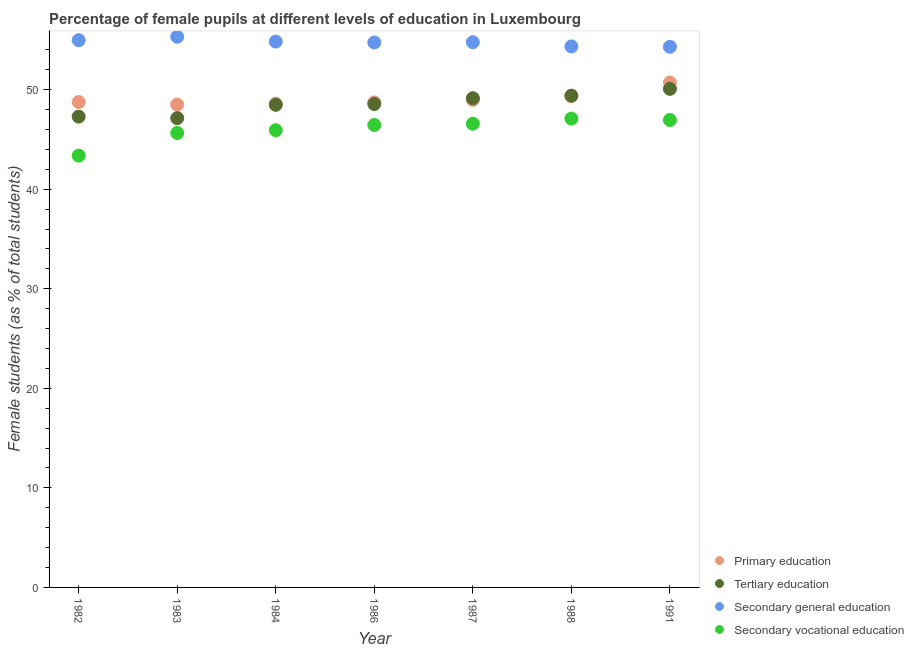Is the number of dotlines equal to the number of legend labels?
Give a very brief answer. Yes. What is the percentage of female students in secondary education in 1991?
Provide a succinct answer. 54.31. Across all years, what is the maximum percentage of female students in primary education?
Provide a succinct answer. 50.72. Across all years, what is the minimum percentage of female students in primary education?
Your response must be concise. 48.5. In which year was the percentage of female students in tertiary education maximum?
Ensure brevity in your answer.  1991. In which year was the percentage of female students in tertiary education minimum?
Your answer should be very brief. 1983. What is the total percentage of female students in secondary education in the graph?
Your answer should be very brief. 383.3. What is the difference between the percentage of female students in tertiary education in 1984 and that in 1986?
Give a very brief answer. -0.08. What is the difference between the percentage of female students in secondary vocational education in 1987 and the percentage of female students in secondary education in 1991?
Provide a short and direct response. -7.72. What is the average percentage of female students in secondary vocational education per year?
Provide a succinct answer. 46.01. In the year 1983, what is the difference between the percentage of female students in secondary education and percentage of female students in primary education?
Your answer should be very brief. 6.81. What is the ratio of the percentage of female students in tertiary education in 1984 to that in 1988?
Offer a very short reply. 0.98. Is the percentage of female students in tertiary education in 1982 less than that in 1987?
Keep it short and to the point. Yes. Is the difference between the percentage of female students in tertiary education in 1983 and 1988 greater than the difference between the percentage of female students in secondary education in 1983 and 1988?
Offer a very short reply. No. What is the difference between the highest and the second highest percentage of female students in primary education?
Keep it short and to the point. 1.38. What is the difference between the highest and the lowest percentage of female students in secondary vocational education?
Offer a very short reply. 3.72. Is it the case that in every year, the sum of the percentage of female students in tertiary education and percentage of female students in secondary education is greater than the sum of percentage of female students in secondary vocational education and percentage of female students in primary education?
Provide a short and direct response. No. Is it the case that in every year, the sum of the percentage of female students in primary education and percentage of female students in tertiary education is greater than the percentage of female students in secondary education?
Ensure brevity in your answer.  Yes. Does the percentage of female students in secondary education monotonically increase over the years?
Give a very brief answer. No. Is the percentage of female students in primary education strictly greater than the percentage of female students in secondary education over the years?
Ensure brevity in your answer.  No. How many dotlines are there?
Offer a terse response. 4. How many years are there in the graph?
Your response must be concise. 7. What is the difference between two consecutive major ticks on the Y-axis?
Your answer should be very brief. 10. Are the values on the major ticks of Y-axis written in scientific E-notation?
Your answer should be compact. No. Does the graph contain grids?
Offer a terse response. No. How many legend labels are there?
Your answer should be very brief. 4. What is the title of the graph?
Your response must be concise. Percentage of female pupils at different levels of education in Luxembourg. What is the label or title of the X-axis?
Your answer should be compact. Year. What is the label or title of the Y-axis?
Give a very brief answer. Female students (as % of total students). What is the Female students (as % of total students) of Primary education in 1982?
Ensure brevity in your answer.  48.76. What is the Female students (as % of total students) in Tertiary education in 1982?
Your answer should be very brief. 47.3. What is the Female students (as % of total students) of Secondary general education in 1982?
Provide a succinct answer. 54.98. What is the Female students (as % of total students) of Secondary vocational education in 1982?
Make the answer very short. 43.38. What is the Female students (as % of total students) in Primary education in 1983?
Your response must be concise. 48.5. What is the Female students (as % of total students) of Tertiary education in 1983?
Provide a succinct answer. 47.14. What is the Female students (as % of total students) in Secondary general education in 1983?
Offer a very short reply. 55.32. What is the Female students (as % of total students) of Secondary vocational education in 1983?
Offer a terse response. 45.65. What is the Female students (as % of total students) of Primary education in 1984?
Keep it short and to the point. 48.6. What is the Female students (as % of total students) in Tertiary education in 1984?
Your answer should be compact. 48.48. What is the Female students (as % of total students) in Secondary general education in 1984?
Your answer should be compact. 54.83. What is the Female students (as % of total students) in Secondary vocational education in 1984?
Your answer should be compact. 45.93. What is the Female students (as % of total students) of Primary education in 1986?
Your answer should be very brief. 48.73. What is the Female students (as % of total students) of Tertiary education in 1986?
Keep it short and to the point. 48.56. What is the Female students (as % of total students) of Secondary general education in 1986?
Make the answer very short. 54.74. What is the Female students (as % of total students) in Secondary vocational education in 1986?
Ensure brevity in your answer.  46.46. What is the Female students (as % of total students) in Primary education in 1987?
Give a very brief answer. 48.98. What is the Female students (as % of total students) of Tertiary education in 1987?
Your response must be concise. 49.15. What is the Female students (as % of total students) of Secondary general education in 1987?
Your answer should be very brief. 54.77. What is the Female students (as % of total students) of Secondary vocational education in 1987?
Your answer should be very brief. 46.58. What is the Female students (as % of total students) of Primary education in 1988?
Your answer should be compact. 49.34. What is the Female students (as % of total students) in Tertiary education in 1988?
Make the answer very short. 49.41. What is the Female students (as % of total students) of Secondary general education in 1988?
Give a very brief answer. 54.35. What is the Female students (as % of total students) in Secondary vocational education in 1988?
Your answer should be compact. 47.1. What is the Female students (as % of total students) in Primary education in 1991?
Give a very brief answer. 50.72. What is the Female students (as % of total students) of Tertiary education in 1991?
Offer a very short reply. 50.08. What is the Female students (as % of total students) in Secondary general education in 1991?
Offer a very short reply. 54.31. What is the Female students (as % of total students) in Secondary vocational education in 1991?
Keep it short and to the point. 46.96. Across all years, what is the maximum Female students (as % of total students) in Primary education?
Your response must be concise. 50.72. Across all years, what is the maximum Female students (as % of total students) in Tertiary education?
Offer a terse response. 50.08. Across all years, what is the maximum Female students (as % of total students) in Secondary general education?
Your answer should be very brief. 55.32. Across all years, what is the maximum Female students (as % of total students) in Secondary vocational education?
Your answer should be very brief. 47.1. Across all years, what is the minimum Female students (as % of total students) in Primary education?
Your response must be concise. 48.5. Across all years, what is the minimum Female students (as % of total students) in Tertiary education?
Give a very brief answer. 47.14. Across all years, what is the minimum Female students (as % of total students) in Secondary general education?
Provide a succinct answer. 54.31. Across all years, what is the minimum Female students (as % of total students) of Secondary vocational education?
Provide a succinct answer. 43.38. What is the total Female students (as % of total students) of Primary education in the graph?
Ensure brevity in your answer.  343.64. What is the total Female students (as % of total students) of Tertiary education in the graph?
Offer a terse response. 340.12. What is the total Female students (as % of total students) of Secondary general education in the graph?
Ensure brevity in your answer.  383.3. What is the total Female students (as % of total students) of Secondary vocational education in the graph?
Provide a succinct answer. 322.06. What is the difference between the Female students (as % of total students) of Primary education in 1982 and that in 1983?
Keep it short and to the point. 0.26. What is the difference between the Female students (as % of total students) in Tertiary education in 1982 and that in 1983?
Offer a very short reply. 0.15. What is the difference between the Female students (as % of total students) of Secondary general education in 1982 and that in 1983?
Keep it short and to the point. -0.34. What is the difference between the Female students (as % of total students) in Secondary vocational education in 1982 and that in 1983?
Give a very brief answer. -2.27. What is the difference between the Female students (as % of total students) of Primary education in 1982 and that in 1984?
Provide a short and direct response. 0.16. What is the difference between the Female students (as % of total students) of Tertiary education in 1982 and that in 1984?
Offer a terse response. -1.18. What is the difference between the Female students (as % of total students) of Secondary general education in 1982 and that in 1984?
Your answer should be very brief. 0.14. What is the difference between the Female students (as % of total students) of Secondary vocational education in 1982 and that in 1984?
Ensure brevity in your answer.  -2.55. What is the difference between the Female students (as % of total students) of Primary education in 1982 and that in 1986?
Keep it short and to the point. 0.04. What is the difference between the Female students (as % of total students) in Tertiary education in 1982 and that in 1986?
Your answer should be compact. -1.27. What is the difference between the Female students (as % of total students) in Secondary general education in 1982 and that in 1986?
Your answer should be compact. 0.24. What is the difference between the Female students (as % of total students) in Secondary vocational education in 1982 and that in 1986?
Make the answer very short. -3.08. What is the difference between the Female students (as % of total students) in Primary education in 1982 and that in 1987?
Provide a short and direct response. -0.22. What is the difference between the Female students (as % of total students) in Tertiary education in 1982 and that in 1987?
Provide a succinct answer. -1.85. What is the difference between the Female students (as % of total students) of Secondary general education in 1982 and that in 1987?
Ensure brevity in your answer.  0.2. What is the difference between the Female students (as % of total students) in Secondary vocational education in 1982 and that in 1987?
Give a very brief answer. -3.2. What is the difference between the Female students (as % of total students) of Primary education in 1982 and that in 1988?
Your response must be concise. -0.58. What is the difference between the Female students (as % of total students) of Tertiary education in 1982 and that in 1988?
Offer a terse response. -2.11. What is the difference between the Female students (as % of total students) in Secondary general education in 1982 and that in 1988?
Ensure brevity in your answer.  0.63. What is the difference between the Female students (as % of total students) of Secondary vocational education in 1982 and that in 1988?
Your answer should be very brief. -3.72. What is the difference between the Female students (as % of total students) in Primary education in 1982 and that in 1991?
Keep it short and to the point. -1.96. What is the difference between the Female students (as % of total students) in Tertiary education in 1982 and that in 1991?
Keep it short and to the point. -2.79. What is the difference between the Female students (as % of total students) of Secondary general education in 1982 and that in 1991?
Give a very brief answer. 0.67. What is the difference between the Female students (as % of total students) of Secondary vocational education in 1982 and that in 1991?
Make the answer very short. -3.58. What is the difference between the Female students (as % of total students) of Primary education in 1983 and that in 1984?
Make the answer very short. -0.1. What is the difference between the Female students (as % of total students) of Tertiary education in 1983 and that in 1984?
Your response must be concise. -1.34. What is the difference between the Female students (as % of total students) in Secondary general education in 1983 and that in 1984?
Provide a succinct answer. 0.48. What is the difference between the Female students (as % of total students) of Secondary vocational education in 1983 and that in 1984?
Your response must be concise. -0.28. What is the difference between the Female students (as % of total students) of Primary education in 1983 and that in 1986?
Provide a short and direct response. -0.22. What is the difference between the Female students (as % of total students) in Tertiary education in 1983 and that in 1986?
Your answer should be compact. -1.42. What is the difference between the Female students (as % of total students) of Secondary general education in 1983 and that in 1986?
Ensure brevity in your answer.  0.58. What is the difference between the Female students (as % of total students) in Secondary vocational education in 1983 and that in 1986?
Your answer should be compact. -0.8. What is the difference between the Female students (as % of total students) of Primary education in 1983 and that in 1987?
Offer a very short reply. -0.48. What is the difference between the Female students (as % of total students) in Tertiary education in 1983 and that in 1987?
Offer a very short reply. -2. What is the difference between the Female students (as % of total students) in Secondary general education in 1983 and that in 1987?
Keep it short and to the point. 0.55. What is the difference between the Female students (as % of total students) of Secondary vocational education in 1983 and that in 1987?
Give a very brief answer. -0.93. What is the difference between the Female students (as % of total students) of Primary education in 1983 and that in 1988?
Ensure brevity in your answer.  -0.84. What is the difference between the Female students (as % of total students) of Tertiary education in 1983 and that in 1988?
Give a very brief answer. -2.26. What is the difference between the Female students (as % of total students) in Secondary general education in 1983 and that in 1988?
Ensure brevity in your answer.  0.97. What is the difference between the Female students (as % of total students) in Secondary vocational education in 1983 and that in 1988?
Make the answer very short. -1.44. What is the difference between the Female students (as % of total students) in Primary education in 1983 and that in 1991?
Provide a short and direct response. -2.22. What is the difference between the Female students (as % of total students) in Tertiary education in 1983 and that in 1991?
Your answer should be compact. -2.94. What is the difference between the Female students (as % of total students) of Secondary general education in 1983 and that in 1991?
Ensure brevity in your answer.  1.01. What is the difference between the Female students (as % of total students) of Secondary vocational education in 1983 and that in 1991?
Offer a terse response. -1.3. What is the difference between the Female students (as % of total students) in Primary education in 1984 and that in 1986?
Make the answer very short. -0.12. What is the difference between the Female students (as % of total students) of Tertiary education in 1984 and that in 1986?
Your answer should be very brief. -0.08. What is the difference between the Female students (as % of total students) of Secondary general education in 1984 and that in 1986?
Ensure brevity in your answer.  0.09. What is the difference between the Female students (as % of total students) of Secondary vocational education in 1984 and that in 1986?
Ensure brevity in your answer.  -0.52. What is the difference between the Female students (as % of total students) in Primary education in 1984 and that in 1987?
Ensure brevity in your answer.  -0.38. What is the difference between the Female students (as % of total students) of Tertiary education in 1984 and that in 1987?
Keep it short and to the point. -0.67. What is the difference between the Female students (as % of total students) of Secondary general education in 1984 and that in 1987?
Keep it short and to the point. 0.06. What is the difference between the Female students (as % of total students) of Secondary vocational education in 1984 and that in 1987?
Provide a succinct answer. -0.65. What is the difference between the Female students (as % of total students) in Primary education in 1984 and that in 1988?
Your response must be concise. -0.74. What is the difference between the Female students (as % of total students) in Tertiary education in 1984 and that in 1988?
Ensure brevity in your answer.  -0.93. What is the difference between the Female students (as % of total students) in Secondary general education in 1984 and that in 1988?
Make the answer very short. 0.49. What is the difference between the Female students (as % of total students) in Secondary vocational education in 1984 and that in 1988?
Your answer should be very brief. -1.17. What is the difference between the Female students (as % of total students) of Primary education in 1984 and that in 1991?
Offer a terse response. -2.12. What is the difference between the Female students (as % of total students) in Tertiary education in 1984 and that in 1991?
Your answer should be very brief. -1.6. What is the difference between the Female students (as % of total students) of Secondary general education in 1984 and that in 1991?
Your answer should be compact. 0.53. What is the difference between the Female students (as % of total students) of Secondary vocational education in 1984 and that in 1991?
Offer a terse response. -1.03. What is the difference between the Female students (as % of total students) in Primary education in 1986 and that in 1987?
Offer a very short reply. -0.26. What is the difference between the Female students (as % of total students) of Tertiary education in 1986 and that in 1987?
Make the answer very short. -0.58. What is the difference between the Female students (as % of total students) of Secondary general education in 1986 and that in 1987?
Your answer should be very brief. -0.03. What is the difference between the Female students (as % of total students) in Secondary vocational education in 1986 and that in 1987?
Provide a short and direct response. -0.13. What is the difference between the Female students (as % of total students) in Primary education in 1986 and that in 1988?
Your answer should be very brief. -0.62. What is the difference between the Female students (as % of total students) in Tertiary education in 1986 and that in 1988?
Give a very brief answer. -0.84. What is the difference between the Female students (as % of total students) in Secondary general education in 1986 and that in 1988?
Make the answer very short. 0.39. What is the difference between the Female students (as % of total students) of Secondary vocational education in 1986 and that in 1988?
Offer a very short reply. -0.64. What is the difference between the Female students (as % of total students) in Primary education in 1986 and that in 1991?
Give a very brief answer. -2. What is the difference between the Female students (as % of total students) of Tertiary education in 1986 and that in 1991?
Provide a succinct answer. -1.52. What is the difference between the Female students (as % of total students) of Secondary general education in 1986 and that in 1991?
Give a very brief answer. 0.43. What is the difference between the Female students (as % of total students) of Secondary vocational education in 1986 and that in 1991?
Give a very brief answer. -0.5. What is the difference between the Female students (as % of total students) in Primary education in 1987 and that in 1988?
Give a very brief answer. -0.36. What is the difference between the Female students (as % of total students) in Tertiary education in 1987 and that in 1988?
Give a very brief answer. -0.26. What is the difference between the Female students (as % of total students) of Secondary general education in 1987 and that in 1988?
Offer a very short reply. 0.42. What is the difference between the Female students (as % of total students) of Secondary vocational education in 1987 and that in 1988?
Provide a succinct answer. -0.51. What is the difference between the Female students (as % of total students) of Primary education in 1987 and that in 1991?
Give a very brief answer. -1.74. What is the difference between the Female students (as % of total students) in Tertiary education in 1987 and that in 1991?
Provide a succinct answer. -0.94. What is the difference between the Female students (as % of total students) of Secondary general education in 1987 and that in 1991?
Your answer should be compact. 0.46. What is the difference between the Female students (as % of total students) of Secondary vocational education in 1987 and that in 1991?
Ensure brevity in your answer.  -0.37. What is the difference between the Female students (as % of total students) of Primary education in 1988 and that in 1991?
Your response must be concise. -1.38. What is the difference between the Female students (as % of total students) in Tertiary education in 1988 and that in 1991?
Provide a succinct answer. -0.68. What is the difference between the Female students (as % of total students) of Secondary general education in 1988 and that in 1991?
Make the answer very short. 0.04. What is the difference between the Female students (as % of total students) of Secondary vocational education in 1988 and that in 1991?
Provide a short and direct response. 0.14. What is the difference between the Female students (as % of total students) of Primary education in 1982 and the Female students (as % of total students) of Tertiary education in 1983?
Your answer should be very brief. 1.62. What is the difference between the Female students (as % of total students) in Primary education in 1982 and the Female students (as % of total students) in Secondary general education in 1983?
Your answer should be very brief. -6.56. What is the difference between the Female students (as % of total students) of Primary education in 1982 and the Female students (as % of total students) of Secondary vocational education in 1983?
Provide a short and direct response. 3.11. What is the difference between the Female students (as % of total students) of Tertiary education in 1982 and the Female students (as % of total students) of Secondary general education in 1983?
Your response must be concise. -8.02. What is the difference between the Female students (as % of total students) in Tertiary education in 1982 and the Female students (as % of total students) in Secondary vocational education in 1983?
Offer a terse response. 1.64. What is the difference between the Female students (as % of total students) in Secondary general education in 1982 and the Female students (as % of total students) in Secondary vocational education in 1983?
Make the answer very short. 9.32. What is the difference between the Female students (as % of total students) of Primary education in 1982 and the Female students (as % of total students) of Tertiary education in 1984?
Keep it short and to the point. 0.28. What is the difference between the Female students (as % of total students) of Primary education in 1982 and the Female students (as % of total students) of Secondary general education in 1984?
Keep it short and to the point. -6.07. What is the difference between the Female students (as % of total students) of Primary education in 1982 and the Female students (as % of total students) of Secondary vocational education in 1984?
Offer a very short reply. 2.83. What is the difference between the Female students (as % of total students) in Tertiary education in 1982 and the Female students (as % of total students) in Secondary general education in 1984?
Provide a succinct answer. -7.54. What is the difference between the Female students (as % of total students) in Tertiary education in 1982 and the Female students (as % of total students) in Secondary vocational education in 1984?
Your answer should be very brief. 1.36. What is the difference between the Female students (as % of total students) of Secondary general education in 1982 and the Female students (as % of total students) of Secondary vocational education in 1984?
Offer a very short reply. 9.05. What is the difference between the Female students (as % of total students) of Primary education in 1982 and the Female students (as % of total students) of Tertiary education in 1986?
Ensure brevity in your answer.  0.2. What is the difference between the Female students (as % of total students) in Primary education in 1982 and the Female students (as % of total students) in Secondary general education in 1986?
Keep it short and to the point. -5.98. What is the difference between the Female students (as % of total students) in Primary education in 1982 and the Female students (as % of total students) in Secondary vocational education in 1986?
Ensure brevity in your answer.  2.31. What is the difference between the Female students (as % of total students) of Tertiary education in 1982 and the Female students (as % of total students) of Secondary general education in 1986?
Your answer should be very brief. -7.45. What is the difference between the Female students (as % of total students) in Tertiary education in 1982 and the Female students (as % of total students) in Secondary vocational education in 1986?
Make the answer very short. 0.84. What is the difference between the Female students (as % of total students) in Secondary general education in 1982 and the Female students (as % of total students) in Secondary vocational education in 1986?
Offer a very short reply. 8.52. What is the difference between the Female students (as % of total students) in Primary education in 1982 and the Female students (as % of total students) in Tertiary education in 1987?
Your answer should be compact. -0.38. What is the difference between the Female students (as % of total students) in Primary education in 1982 and the Female students (as % of total students) in Secondary general education in 1987?
Your answer should be compact. -6.01. What is the difference between the Female students (as % of total students) of Primary education in 1982 and the Female students (as % of total students) of Secondary vocational education in 1987?
Your response must be concise. 2.18. What is the difference between the Female students (as % of total students) in Tertiary education in 1982 and the Female students (as % of total students) in Secondary general education in 1987?
Provide a short and direct response. -7.48. What is the difference between the Female students (as % of total students) in Tertiary education in 1982 and the Female students (as % of total students) in Secondary vocational education in 1987?
Your response must be concise. 0.71. What is the difference between the Female students (as % of total students) in Secondary general education in 1982 and the Female students (as % of total students) in Secondary vocational education in 1987?
Offer a terse response. 8.39. What is the difference between the Female students (as % of total students) of Primary education in 1982 and the Female students (as % of total students) of Tertiary education in 1988?
Offer a very short reply. -0.64. What is the difference between the Female students (as % of total students) of Primary education in 1982 and the Female students (as % of total students) of Secondary general education in 1988?
Ensure brevity in your answer.  -5.59. What is the difference between the Female students (as % of total students) of Primary education in 1982 and the Female students (as % of total students) of Secondary vocational education in 1988?
Your answer should be compact. 1.66. What is the difference between the Female students (as % of total students) of Tertiary education in 1982 and the Female students (as % of total students) of Secondary general education in 1988?
Provide a short and direct response. -7.05. What is the difference between the Female students (as % of total students) in Tertiary education in 1982 and the Female students (as % of total students) in Secondary vocational education in 1988?
Your response must be concise. 0.2. What is the difference between the Female students (as % of total students) of Secondary general education in 1982 and the Female students (as % of total students) of Secondary vocational education in 1988?
Offer a terse response. 7.88. What is the difference between the Female students (as % of total students) in Primary education in 1982 and the Female students (as % of total students) in Tertiary education in 1991?
Offer a very short reply. -1.32. What is the difference between the Female students (as % of total students) in Primary education in 1982 and the Female students (as % of total students) in Secondary general education in 1991?
Your answer should be very brief. -5.55. What is the difference between the Female students (as % of total students) of Primary education in 1982 and the Female students (as % of total students) of Secondary vocational education in 1991?
Provide a succinct answer. 1.8. What is the difference between the Female students (as % of total students) in Tertiary education in 1982 and the Female students (as % of total students) in Secondary general education in 1991?
Ensure brevity in your answer.  -7.01. What is the difference between the Female students (as % of total students) of Tertiary education in 1982 and the Female students (as % of total students) of Secondary vocational education in 1991?
Your response must be concise. 0.34. What is the difference between the Female students (as % of total students) in Secondary general education in 1982 and the Female students (as % of total students) in Secondary vocational education in 1991?
Provide a succinct answer. 8.02. What is the difference between the Female students (as % of total students) of Primary education in 1983 and the Female students (as % of total students) of Tertiary education in 1984?
Make the answer very short. 0.02. What is the difference between the Female students (as % of total students) of Primary education in 1983 and the Female students (as % of total students) of Secondary general education in 1984?
Offer a very short reply. -6.33. What is the difference between the Female students (as % of total students) in Primary education in 1983 and the Female students (as % of total students) in Secondary vocational education in 1984?
Offer a terse response. 2.57. What is the difference between the Female students (as % of total students) in Tertiary education in 1983 and the Female students (as % of total students) in Secondary general education in 1984?
Offer a very short reply. -7.69. What is the difference between the Female students (as % of total students) of Tertiary education in 1983 and the Female students (as % of total students) of Secondary vocational education in 1984?
Offer a terse response. 1.21. What is the difference between the Female students (as % of total students) in Secondary general education in 1983 and the Female students (as % of total students) in Secondary vocational education in 1984?
Give a very brief answer. 9.39. What is the difference between the Female students (as % of total students) in Primary education in 1983 and the Female students (as % of total students) in Tertiary education in 1986?
Your answer should be compact. -0.06. What is the difference between the Female students (as % of total students) in Primary education in 1983 and the Female students (as % of total students) in Secondary general education in 1986?
Provide a succinct answer. -6.24. What is the difference between the Female students (as % of total students) of Primary education in 1983 and the Female students (as % of total students) of Secondary vocational education in 1986?
Ensure brevity in your answer.  2.05. What is the difference between the Female students (as % of total students) in Tertiary education in 1983 and the Female students (as % of total students) in Secondary general education in 1986?
Give a very brief answer. -7.6. What is the difference between the Female students (as % of total students) in Tertiary education in 1983 and the Female students (as % of total students) in Secondary vocational education in 1986?
Offer a very short reply. 0.69. What is the difference between the Female students (as % of total students) in Secondary general education in 1983 and the Female students (as % of total students) in Secondary vocational education in 1986?
Ensure brevity in your answer.  8.86. What is the difference between the Female students (as % of total students) of Primary education in 1983 and the Female students (as % of total students) of Tertiary education in 1987?
Your answer should be compact. -0.64. What is the difference between the Female students (as % of total students) of Primary education in 1983 and the Female students (as % of total students) of Secondary general education in 1987?
Offer a very short reply. -6.27. What is the difference between the Female students (as % of total students) of Primary education in 1983 and the Female students (as % of total students) of Secondary vocational education in 1987?
Offer a terse response. 1.92. What is the difference between the Female students (as % of total students) of Tertiary education in 1983 and the Female students (as % of total students) of Secondary general education in 1987?
Your answer should be compact. -7.63. What is the difference between the Female students (as % of total students) of Tertiary education in 1983 and the Female students (as % of total students) of Secondary vocational education in 1987?
Your response must be concise. 0.56. What is the difference between the Female students (as % of total students) in Secondary general education in 1983 and the Female students (as % of total students) in Secondary vocational education in 1987?
Give a very brief answer. 8.73. What is the difference between the Female students (as % of total students) of Primary education in 1983 and the Female students (as % of total students) of Tertiary education in 1988?
Provide a succinct answer. -0.9. What is the difference between the Female students (as % of total students) of Primary education in 1983 and the Female students (as % of total students) of Secondary general education in 1988?
Ensure brevity in your answer.  -5.85. What is the difference between the Female students (as % of total students) of Primary education in 1983 and the Female students (as % of total students) of Secondary vocational education in 1988?
Keep it short and to the point. 1.4. What is the difference between the Female students (as % of total students) in Tertiary education in 1983 and the Female students (as % of total students) in Secondary general education in 1988?
Offer a terse response. -7.2. What is the difference between the Female students (as % of total students) of Tertiary education in 1983 and the Female students (as % of total students) of Secondary vocational education in 1988?
Make the answer very short. 0.05. What is the difference between the Female students (as % of total students) in Secondary general education in 1983 and the Female students (as % of total students) in Secondary vocational education in 1988?
Your answer should be very brief. 8.22. What is the difference between the Female students (as % of total students) of Primary education in 1983 and the Female students (as % of total students) of Tertiary education in 1991?
Offer a terse response. -1.58. What is the difference between the Female students (as % of total students) of Primary education in 1983 and the Female students (as % of total students) of Secondary general education in 1991?
Your answer should be compact. -5.81. What is the difference between the Female students (as % of total students) in Primary education in 1983 and the Female students (as % of total students) in Secondary vocational education in 1991?
Your answer should be very brief. 1.54. What is the difference between the Female students (as % of total students) in Tertiary education in 1983 and the Female students (as % of total students) in Secondary general education in 1991?
Your response must be concise. -7.16. What is the difference between the Female students (as % of total students) in Tertiary education in 1983 and the Female students (as % of total students) in Secondary vocational education in 1991?
Keep it short and to the point. 0.19. What is the difference between the Female students (as % of total students) of Secondary general education in 1983 and the Female students (as % of total students) of Secondary vocational education in 1991?
Give a very brief answer. 8.36. What is the difference between the Female students (as % of total students) in Primary education in 1984 and the Female students (as % of total students) in Tertiary education in 1986?
Keep it short and to the point. 0.04. What is the difference between the Female students (as % of total students) in Primary education in 1984 and the Female students (as % of total students) in Secondary general education in 1986?
Your answer should be compact. -6.14. What is the difference between the Female students (as % of total students) of Primary education in 1984 and the Female students (as % of total students) of Secondary vocational education in 1986?
Make the answer very short. 2.14. What is the difference between the Female students (as % of total students) of Tertiary education in 1984 and the Female students (as % of total students) of Secondary general education in 1986?
Ensure brevity in your answer.  -6.26. What is the difference between the Female students (as % of total students) in Tertiary education in 1984 and the Female students (as % of total students) in Secondary vocational education in 1986?
Offer a terse response. 2.02. What is the difference between the Female students (as % of total students) of Secondary general education in 1984 and the Female students (as % of total students) of Secondary vocational education in 1986?
Your answer should be very brief. 8.38. What is the difference between the Female students (as % of total students) of Primary education in 1984 and the Female students (as % of total students) of Tertiary education in 1987?
Your answer should be compact. -0.55. What is the difference between the Female students (as % of total students) of Primary education in 1984 and the Female students (as % of total students) of Secondary general education in 1987?
Your response must be concise. -6.17. What is the difference between the Female students (as % of total students) of Primary education in 1984 and the Female students (as % of total students) of Secondary vocational education in 1987?
Keep it short and to the point. 2.02. What is the difference between the Female students (as % of total students) in Tertiary education in 1984 and the Female students (as % of total students) in Secondary general education in 1987?
Offer a terse response. -6.29. What is the difference between the Female students (as % of total students) in Tertiary education in 1984 and the Female students (as % of total students) in Secondary vocational education in 1987?
Offer a very short reply. 1.9. What is the difference between the Female students (as % of total students) in Secondary general education in 1984 and the Female students (as % of total students) in Secondary vocational education in 1987?
Your answer should be very brief. 8.25. What is the difference between the Female students (as % of total students) in Primary education in 1984 and the Female students (as % of total students) in Tertiary education in 1988?
Ensure brevity in your answer.  -0.81. What is the difference between the Female students (as % of total students) of Primary education in 1984 and the Female students (as % of total students) of Secondary general education in 1988?
Make the answer very short. -5.75. What is the difference between the Female students (as % of total students) in Primary education in 1984 and the Female students (as % of total students) in Secondary vocational education in 1988?
Provide a short and direct response. 1.5. What is the difference between the Female students (as % of total students) in Tertiary education in 1984 and the Female students (as % of total students) in Secondary general education in 1988?
Your response must be concise. -5.87. What is the difference between the Female students (as % of total students) of Tertiary education in 1984 and the Female students (as % of total students) of Secondary vocational education in 1988?
Provide a short and direct response. 1.38. What is the difference between the Female students (as % of total students) in Secondary general education in 1984 and the Female students (as % of total students) in Secondary vocational education in 1988?
Make the answer very short. 7.74. What is the difference between the Female students (as % of total students) in Primary education in 1984 and the Female students (as % of total students) in Tertiary education in 1991?
Provide a short and direct response. -1.48. What is the difference between the Female students (as % of total students) in Primary education in 1984 and the Female students (as % of total students) in Secondary general education in 1991?
Ensure brevity in your answer.  -5.71. What is the difference between the Female students (as % of total students) in Primary education in 1984 and the Female students (as % of total students) in Secondary vocational education in 1991?
Give a very brief answer. 1.64. What is the difference between the Female students (as % of total students) of Tertiary education in 1984 and the Female students (as % of total students) of Secondary general education in 1991?
Your answer should be compact. -5.83. What is the difference between the Female students (as % of total students) of Tertiary education in 1984 and the Female students (as % of total students) of Secondary vocational education in 1991?
Your response must be concise. 1.52. What is the difference between the Female students (as % of total students) of Secondary general education in 1984 and the Female students (as % of total students) of Secondary vocational education in 1991?
Make the answer very short. 7.88. What is the difference between the Female students (as % of total students) of Primary education in 1986 and the Female students (as % of total students) of Tertiary education in 1987?
Your response must be concise. -0.42. What is the difference between the Female students (as % of total students) of Primary education in 1986 and the Female students (as % of total students) of Secondary general education in 1987?
Make the answer very short. -6.05. What is the difference between the Female students (as % of total students) of Primary education in 1986 and the Female students (as % of total students) of Secondary vocational education in 1987?
Your answer should be compact. 2.14. What is the difference between the Female students (as % of total students) of Tertiary education in 1986 and the Female students (as % of total students) of Secondary general education in 1987?
Provide a short and direct response. -6.21. What is the difference between the Female students (as % of total students) of Tertiary education in 1986 and the Female students (as % of total students) of Secondary vocational education in 1987?
Your response must be concise. 1.98. What is the difference between the Female students (as % of total students) of Secondary general education in 1986 and the Female students (as % of total students) of Secondary vocational education in 1987?
Give a very brief answer. 8.16. What is the difference between the Female students (as % of total students) of Primary education in 1986 and the Female students (as % of total students) of Tertiary education in 1988?
Keep it short and to the point. -0.68. What is the difference between the Female students (as % of total students) of Primary education in 1986 and the Female students (as % of total students) of Secondary general education in 1988?
Offer a terse response. -5.62. What is the difference between the Female students (as % of total students) of Primary education in 1986 and the Female students (as % of total students) of Secondary vocational education in 1988?
Offer a terse response. 1.63. What is the difference between the Female students (as % of total students) of Tertiary education in 1986 and the Female students (as % of total students) of Secondary general education in 1988?
Provide a succinct answer. -5.79. What is the difference between the Female students (as % of total students) in Tertiary education in 1986 and the Female students (as % of total students) in Secondary vocational education in 1988?
Offer a very short reply. 1.46. What is the difference between the Female students (as % of total students) of Secondary general education in 1986 and the Female students (as % of total students) of Secondary vocational education in 1988?
Ensure brevity in your answer.  7.64. What is the difference between the Female students (as % of total students) of Primary education in 1986 and the Female students (as % of total students) of Tertiary education in 1991?
Keep it short and to the point. -1.36. What is the difference between the Female students (as % of total students) in Primary education in 1986 and the Female students (as % of total students) in Secondary general education in 1991?
Your answer should be compact. -5.58. What is the difference between the Female students (as % of total students) in Primary education in 1986 and the Female students (as % of total students) in Secondary vocational education in 1991?
Offer a terse response. 1.77. What is the difference between the Female students (as % of total students) in Tertiary education in 1986 and the Female students (as % of total students) in Secondary general education in 1991?
Offer a terse response. -5.75. What is the difference between the Female students (as % of total students) of Tertiary education in 1986 and the Female students (as % of total students) of Secondary vocational education in 1991?
Your answer should be very brief. 1.6. What is the difference between the Female students (as % of total students) in Secondary general education in 1986 and the Female students (as % of total students) in Secondary vocational education in 1991?
Provide a succinct answer. 7.78. What is the difference between the Female students (as % of total students) of Primary education in 1987 and the Female students (as % of total students) of Tertiary education in 1988?
Your answer should be very brief. -0.42. What is the difference between the Female students (as % of total students) of Primary education in 1987 and the Female students (as % of total students) of Secondary general education in 1988?
Give a very brief answer. -5.37. What is the difference between the Female students (as % of total students) in Primary education in 1987 and the Female students (as % of total students) in Secondary vocational education in 1988?
Ensure brevity in your answer.  1.88. What is the difference between the Female students (as % of total students) in Tertiary education in 1987 and the Female students (as % of total students) in Secondary general education in 1988?
Your answer should be very brief. -5.2. What is the difference between the Female students (as % of total students) of Tertiary education in 1987 and the Female students (as % of total students) of Secondary vocational education in 1988?
Keep it short and to the point. 2.05. What is the difference between the Female students (as % of total students) of Secondary general education in 1987 and the Female students (as % of total students) of Secondary vocational education in 1988?
Provide a succinct answer. 7.67. What is the difference between the Female students (as % of total students) in Primary education in 1987 and the Female students (as % of total students) in Tertiary education in 1991?
Keep it short and to the point. -1.1. What is the difference between the Female students (as % of total students) in Primary education in 1987 and the Female students (as % of total students) in Secondary general education in 1991?
Your answer should be compact. -5.33. What is the difference between the Female students (as % of total students) of Primary education in 1987 and the Female students (as % of total students) of Secondary vocational education in 1991?
Your response must be concise. 2.02. What is the difference between the Female students (as % of total students) of Tertiary education in 1987 and the Female students (as % of total students) of Secondary general education in 1991?
Give a very brief answer. -5.16. What is the difference between the Female students (as % of total students) of Tertiary education in 1987 and the Female students (as % of total students) of Secondary vocational education in 1991?
Make the answer very short. 2.19. What is the difference between the Female students (as % of total students) in Secondary general education in 1987 and the Female students (as % of total students) in Secondary vocational education in 1991?
Keep it short and to the point. 7.81. What is the difference between the Female students (as % of total students) in Primary education in 1988 and the Female students (as % of total students) in Tertiary education in 1991?
Your answer should be compact. -0.74. What is the difference between the Female students (as % of total students) in Primary education in 1988 and the Female students (as % of total students) in Secondary general education in 1991?
Give a very brief answer. -4.96. What is the difference between the Female students (as % of total students) of Primary education in 1988 and the Female students (as % of total students) of Secondary vocational education in 1991?
Your answer should be very brief. 2.39. What is the difference between the Female students (as % of total students) of Tertiary education in 1988 and the Female students (as % of total students) of Secondary general education in 1991?
Give a very brief answer. -4.9. What is the difference between the Female students (as % of total students) in Tertiary education in 1988 and the Female students (as % of total students) in Secondary vocational education in 1991?
Give a very brief answer. 2.45. What is the difference between the Female students (as % of total students) of Secondary general education in 1988 and the Female students (as % of total students) of Secondary vocational education in 1991?
Provide a short and direct response. 7.39. What is the average Female students (as % of total students) of Primary education per year?
Your answer should be compact. 49.09. What is the average Female students (as % of total students) of Tertiary education per year?
Keep it short and to the point. 48.59. What is the average Female students (as % of total students) of Secondary general education per year?
Offer a very short reply. 54.76. What is the average Female students (as % of total students) in Secondary vocational education per year?
Offer a terse response. 46.01. In the year 1982, what is the difference between the Female students (as % of total students) of Primary education and Female students (as % of total students) of Tertiary education?
Make the answer very short. 1.47. In the year 1982, what is the difference between the Female students (as % of total students) in Primary education and Female students (as % of total students) in Secondary general education?
Your response must be concise. -6.22. In the year 1982, what is the difference between the Female students (as % of total students) of Primary education and Female students (as % of total students) of Secondary vocational education?
Your answer should be very brief. 5.38. In the year 1982, what is the difference between the Female students (as % of total students) of Tertiary education and Female students (as % of total students) of Secondary general education?
Make the answer very short. -7.68. In the year 1982, what is the difference between the Female students (as % of total students) in Tertiary education and Female students (as % of total students) in Secondary vocational education?
Keep it short and to the point. 3.92. In the year 1982, what is the difference between the Female students (as % of total students) of Secondary general education and Female students (as % of total students) of Secondary vocational education?
Your answer should be compact. 11.6. In the year 1983, what is the difference between the Female students (as % of total students) of Primary education and Female students (as % of total students) of Tertiary education?
Offer a very short reply. 1.36. In the year 1983, what is the difference between the Female students (as % of total students) of Primary education and Female students (as % of total students) of Secondary general education?
Offer a very short reply. -6.81. In the year 1983, what is the difference between the Female students (as % of total students) in Primary education and Female students (as % of total students) in Secondary vocational education?
Your response must be concise. 2.85. In the year 1983, what is the difference between the Female students (as % of total students) in Tertiary education and Female students (as % of total students) in Secondary general education?
Ensure brevity in your answer.  -8.17. In the year 1983, what is the difference between the Female students (as % of total students) of Tertiary education and Female students (as % of total students) of Secondary vocational education?
Ensure brevity in your answer.  1.49. In the year 1983, what is the difference between the Female students (as % of total students) in Secondary general education and Female students (as % of total students) in Secondary vocational education?
Keep it short and to the point. 9.66. In the year 1984, what is the difference between the Female students (as % of total students) of Primary education and Female students (as % of total students) of Tertiary education?
Give a very brief answer. 0.12. In the year 1984, what is the difference between the Female students (as % of total students) of Primary education and Female students (as % of total students) of Secondary general education?
Ensure brevity in your answer.  -6.23. In the year 1984, what is the difference between the Female students (as % of total students) in Primary education and Female students (as % of total students) in Secondary vocational education?
Your response must be concise. 2.67. In the year 1984, what is the difference between the Female students (as % of total students) in Tertiary education and Female students (as % of total students) in Secondary general education?
Your response must be concise. -6.35. In the year 1984, what is the difference between the Female students (as % of total students) of Tertiary education and Female students (as % of total students) of Secondary vocational education?
Ensure brevity in your answer.  2.55. In the year 1984, what is the difference between the Female students (as % of total students) in Secondary general education and Female students (as % of total students) in Secondary vocational education?
Ensure brevity in your answer.  8.9. In the year 1986, what is the difference between the Female students (as % of total students) of Primary education and Female students (as % of total students) of Tertiary education?
Offer a terse response. 0.16. In the year 1986, what is the difference between the Female students (as % of total students) in Primary education and Female students (as % of total students) in Secondary general education?
Provide a succinct answer. -6.02. In the year 1986, what is the difference between the Female students (as % of total students) of Primary education and Female students (as % of total students) of Secondary vocational education?
Ensure brevity in your answer.  2.27. In the year 1986, what is the difference between the Female students (as % of total students) in Tertiary education and Female students (as % of total students) in Secondary general education?
Give a very brief answer. -6.18. In the year 1986, what is the difference between the Female students (as % of total students) in Tertiary education and Female students (as % of total students) in Secondary vocational education?
Provide a short and direct response. 2.11. In the year 1986, what is the difference between the Female students (as % of total students) in Secondary general education and Female students (as % of total students) in Secondary vocational education?
Provide a short and direct response. 8.28. In the year 1987, what is the difference between the Female students (as % of total students) of Primary education and Female students (as % of total students) of Tertiary education?
Your answer should be very brief. -0.16. In the year 1987, what is the difference between the Female students (as % of total students) in Primary education and Female students (as % of total students) in Secondary general education?
Your answer should be compact. -5.79. In the year 1987, what is the difference between the Female students (as % of total students) of Primary education and Female students (as % of total students) of Secondary vocational education?
Provide a succinct answer. 2.4. In the year 1987, what is the difference between the Female students (as % of total students) in Tertiary education and Female students (as % of total students) in Secondary general education?
Your response must be concise. -5.63. In the year 1987, what is the difference between the Female students (as % of total students) in Tertiary education and Female students (as % of total students) in Secondary vocational education?
Your response must be concise. 2.56. In the year 1987, what is the difference between the Female students (as % of total students) in Secondary general education and Female students (as % of total students) in Secondary vocational education?
Keep it short and to the point. 8.19. In the year 1988, what is the difference between the Female students (as % of total students) of Primary education and Female students (as % of total students) of Tertiary education?
Give a very brief answer. -0.06. In the year 1988, what is the difference between the Female students (as % of total students) of Primary education and Female students (as % of total students) of Secondary general education?
Keep it short and to the point. -5.01. In the year 1988, what is the difference between the Female students (as % of total students) of Primary education and Female students (as % of total students) of Secondary vocational education?
Offer a very short reply. 2.24. In the year 1988, what is the difference between the Female students (as % of total students) of Tertiary education and Female students (as % of total students) of Secondary general education?
Offer a very short reply. -4.94. In the year 1988, what is the difference between the Female students (as % of total students) in Tertiary education and Female students (as % of total students) in Secondary vocational education?
Offer a very short reply. 2.31. In the year 1988, what is the difference between the Female students (as % of total students) of Secondary general education and Female students (as % of total students) of Secondary vocational education?
Your response must be concise. 7.25. In the year 1991, what is the difference between the Female students (as % of total students) of Primary education and Female students (as % of total students) of Tertiary education?
Provide a short and direct response. 0.64. In the year 1991, what is the difference between the Female students (as % of total students) in Primary education and Female students (as % of total students) in Secondary general education?
Offer a terse response. -3.59. In the year 1991, what is the difference between the Female students (as % of total students) of Primary education and Female students (as % of total students) of Secondary vocational education?
Make the answer very short. 3.76. In the year 1991, what is the difference between the Female students (as % of total students) of Tertiary education and Female students (as % of total students) of Secondary general education?
Keep it short and to the point. -4.22. In the year 1991, what is the difference between the Female students (as % of total students) in Tertiary education and Female students (as % of total students) in Secondary vocational education?
Provide a succinct answer. 3.13. In the year 1991, what is the difference between the Female students (as % of total students) of Secondary general education and Female students (as % of total students) of Secondary vocational education?
Offer a terse response. 7.35. What is the ratio of the Female students (as % of total students) in Primary education in 1982 to that in 1983?
Make the answer very short. 1.01. What is the ratio of the Female students (as % of total students) of Secondary vocational education in 1982 to that in 1983?
Offer a terse response. 0.95. What is the ratio of the Female students (as % of total students) in Tertiary education in 1982 to that in 1984?
Offer a very short reply. 0.98. What is the ratio of the Female students (as % of total students) of Primary education in 1982 to that in 1986?
Your response must be concise. 1. What is the ratio of the Female students (as % of total students) in Tertiary education in 1982 to that in 1986?
Provide a succinct answer. 0.97. What is the ratio of the Female students (as % of total students) in Secondary vocational education in 1982 to that in 1986?
Ensure brevity in your answer.  0.93. What is the ratio of the Female students (as % of total students) in Primary education in 1982 to that in 1987?
Offer a very short reply. 1. What is the ratio of the Female students (as % of total students) in Tertiary education in 1982 to that in 1987?
Offer a terse response. 0.96. What is the ratio of the Female students (as % of total students) in Secondary general education in 1982 to that in 1987?
Keep it short and to the point. 1. What is the ratio of the Female students (as % of total students) in Secondary vocational education in 1982 to that in 1987?
Your answer should be compact. 0.93. What is the ratio of the Female students (as % of total students) in Tertiary education in 1982 to that in 1988?
Provide a succinct answer. 0.96. What is the ratio of the Female students (as % of total students) in Secondary general education in 1982 to that in 1988?
Provide a short and direct response. 1.01. What is the ratio of the Female students (as % of total students) in Secondary vocational education in 1982 to that in 1988?
Your answer should be compact. 0.92. What is the ratio of the Female students (as % of total students) in Primary education in 1982 to that in 1991?
Keep it short and to the point. 0.96. What is the ratio of the Female students (as % of total students) of Tertiary education in 1982 to that in 1991?
Your answer should be very brief. 0.94. What is the ratio of the Female students (as % of total students) in Secondary general education in 1982 to that in 1991?
Offer a terse response. 1.01. What is the ratio of the Female students (as % of total students) of Secondary vocational education in 1982 to that in 1991?
Ensure brevity in your answer.  0.92. What is the ratio of the Female students (as % of total students) of Primary education in 1983 to that in 1984?
Ensure brevity in your answer.  1. What is the ratio of the Female students (as % of total students) in Tertiary education in 1983 to that in 1984?
Offer a very short reply. 0.97. What is the ratio of the Female students (as % of total students) in Secondary general education in 1983 to that in 1984?
Offer a terse response. 1.01. What is the ratio of the Female students (as % of total students) in Secondary vocational education in 1983 to that in 1984?
Offer a terse response. 0.99. What is the ratio of the Female students (as % of total students) in Primary education in 1983 to that in 1986?
Your answer should be very brief. 1. What is the ratio of the Female students (as % of total students) in Tertiary education in 1983 to that in 1986?
Your answer should be compact. 0.97. What is the ratio of the Female students (as % of total students) in Secondary general education in 1983 to that in 1986?
Provide a short and direct response. 1.01. What is the ratio of the Female students (as % of total students) of Secondary vocational education in 1983 to that in 1986?
Offer a very short reply. 0.98. What is the ratio of the Female students (as % of total students) in Primary education in 1983 to that in 1987?
Give a very brief answer. 0.99. What is the ratio of the Female students (as % of total students) in Tertiary education in 1983 to that in 1987?
Offer a terse response. 0.96. What is the ratio of the Female students (as % of total students) in Secondary general education in 1983 to that in 1987?
Ensure brevity in your answer.  1.01. What is the ratio of the Female students (as % of total students) of Tertiary education in 1983 to that in 1988?
Ensure brevity in your answer.  0.95. What is the ratio of the Female students (as % of total students) of Secondary general education in 1983 to that in 1988?
Provide a succinct answer. 1.02. What is the ratio of the Female students (as % of total students) of Secondary vocational education in 1983 to that in 1988?
Your answer should be compact. 0.97. What is the ratio of the Female students (as % of total students) of Primary education in 1983 to that in 1991?
Provide a short and direct response. 0.96. What is the ratio of the Female students (as % of total students) of Tertiary education in 1983 to that in 1991?
Offer a terse response. 0.94. What is the ratio of the Female students (as % of total students) in Secondary general education in 1983 to that in 1991?
Your answer should be compact. 1.02. What is the ratio of the Female students (as % of total students) in Secondary vocational education in 1983 to that in 1991?
Your response must be concise. 0.97. What is the ratio of the Female students (as % of total students) in Primary education in 1984 to that in 1986?
Ensure brevity in your answer.  1. What is the ratio of the Female students (as % of total students) in Secondary vocational education in 1984 to that in 1986?
Your answer should be compact. 0.99. What is the ratio of the Female students (as % of total students) in Tertiary education in 1984 to that in 1987?
Your response must be concise. 0.99. What is the ratio of the Female students (as % of total students) in Primary education in 1984 to that in 1988?
Offer a terse response. 0.98. What is the ratio of the Female students (as % of total students) of Tertiary education in 1984 to that in 1988?
Provide a succinct answer. 0.98. What is the ratio of the Female students (as % of total students) of Secondary general education in 1984 to that in 1988?
Make the answer very short. 1.01. What is the ratio of the Female students (as % of total students) in Secondary vocational education in 1984 to that in 1988?
Your answer should be very brief. 0.98. What is the ratio of the Female students (as % of total students) of Primary education in 1984 to that in 1991?
Give a very brief answer. 0.96. What is the ratio of the Female students (as % of total students) of Secondary general education in 1984 to that in 1991?
Offer a very short reply. 1.01. What is the ratio of the Female students (as % of total students) of Secondary vocational education in 1984 to that in 1991?
Provide a short and direct response. 0.98. What is the ratio of the Female students (as % of total students) in Tertiary education in 1986 to that in 1987?
Make the answer very short. 0.99. What is the ratio of the Female students (as % of total students) in Primary education in 1986 to that in 1988?
Provide a short and direct response. 0.99. What is the ratio of the Female students (as % of total students) of Tertiary education in 1986 to that in 1988?
Make the answer very short. 0.98. What is the ratio of the Female students (as % of total students) in Secondary vocational education in 1986 to that in 1988?
Your answer should be compact. 0.99. What is the ratio of the Female students (as % of total students) of Primary education in 1986 to that in 1991?
Provide a succinct answer. 0.96. What is the ratio of the Female students (as % of total students) of Tertiary education in 1986 to that in 1991?
Provide a succinct answer. 0.97. What is the ratio of the Female students (as % of total students) of Secondary general education in 1986 to that in 1991?
Your answer should be compact. 1.01. What is the ratio of the Female students (as % of total students) in Secondary vocational education in 1986 to that in 1991?
Your response must be concise. 0.99. What is the ratio of the Female students (as % of total students) of Primary education in 1987 to that in 1988?
Offer a very short reply. 0.99. What is the ratio of the Female students (as % of total students) of Secondary general education in 1987 to that in 1988?
Give a very brief answer. 1.01. What is the ratio of the Female students (as % of total students) of Primary education in 1987 to that in 1991?
Offer a terse response. 0.97. What is the ratio of the Female students (as % of total students) of Tertiary education in 1987 to that in 1991?
Your answer should be compact. 0.98. What is the ratio of the Female students (as % of total students) in Secondary general education in 1987 to that in 1991?
Your answer should be very brief. 1.01. What is the ratio of the Female students (as % of total students) of Secondary vocational education in 1987 to that in 1991?
Offer a terse response. 0.99. What is the ratio of the Female students (as % of total students) in Primary education in 1988 to that in 1991?
Your answer should be very brief. 0.97. What is the ratio of the Female students (as % of total students) of Tertiary education in 1988 to that in 1991?
Provide a succinct answer. 0.99. What is the ratio of the Female students (as % of total students) in Secondary general education in 1988 to that in 1991?
Keep it short and to the point. 1. What is the ratio of the Female students (as % of total students) of Secondary vocational education in 1988 to that in 1991?
Make the answer very short. 1. What is the difference between the highest and the second highest Female students (as % of total students) in Primary education?
Offer a very short reply. 1.38. What is the difference between the highest and the second highest Female students (as % of total students) in Tertiary education?
Your response must be concise. 0.68. What is the difference between the highest and the second highest Female students (as % of total students) in Secondary general education?
Your response must be concise. 0.34. What is the difference between the highest and the second highest Female students (as % of total students) of Secondary vocational education?
Offer a very short reply. 0.14. What is the difference between the highest and the lowest Female students (as % of total students) in Primary education?
Your answer should be compact. 2.22. What is the difference between the highest and the lowest Female students (as % of total students) of Tertiary education?
Provide a succinct answer. 2.94. What is the difference between the highest and the lowest Female students (as % of total students) of Secondary general education?
Offer a very short reply. 1.01. What is the difference between the highest and the lowest Female students (as % of total students) of Secondary vocational education?
Your response must be concise. 3.72. 